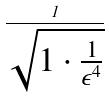<formula> <loc_0><loc_0><loc_500><loc_500>\frac { 1 } { \sqrt { 1 \cdot \frac { 1 } { \epsilon ^ { 4 } } } }</formula> 